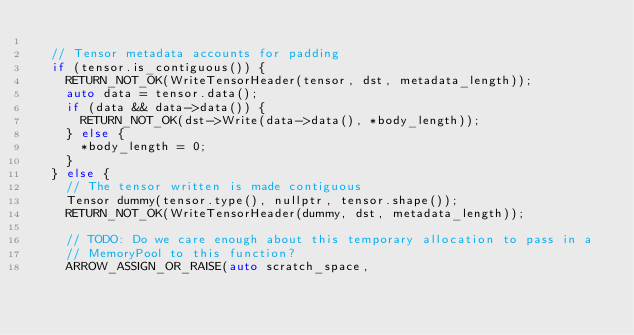Convert code to text. <code><loc_0><loc_0><loc_500><loc_500><_C++_>
  // Tensor metadata accounts for padding
  if (tensor.is_contiguous()) {
    RETURN_NOT_OK(WriteTensorHeader(tensor, dst, metadata_length));
    auto data = tensor.data();
    if (data && data->data()) {
      RETURN_NOT_OK(dst->Write(data->data(), *body_length));
    } else {
      *body_length = 0;
    }
  } else {
    // The tensor written is made contiguous
    Tensor dummy(tensor.type(), nullptr, tensor.shape());
    RETURN_NOT_OK(WriteTensorHeader(dummy, dst, metadata_length));

    // TODO: Do we care enough about this temporary allocation to pass in a
    // MemoryPool to this function?
    ARROW_ASSIGN_OR_RAISE(auto scratch_space,</code> 